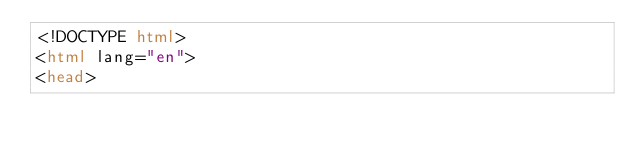Convert code to text. <code><loc_0><loc_0><loc_500><loc_500><_HTML_><!DOCTYPE html>
<html lang="en">
<head></code> 